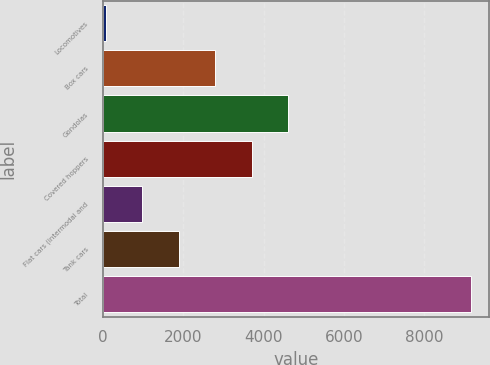Convert chart to OTSL. <chart><loc_0><loc_0><loc_500><loc_500><bar_chart><fcel>Locomotives<fcel>Box cars<fcel>Gondolas<fcel>Covered hoppers<fcel>Flat cars (intermodal and<fcel>Tank cars<fcel>Total<nl><fcel>75<fcel>2796.3<fcel>4610.5<fcel>3703.4<fcel>982.1<fcel>1889.2<fcel>9146<nl></chart> 